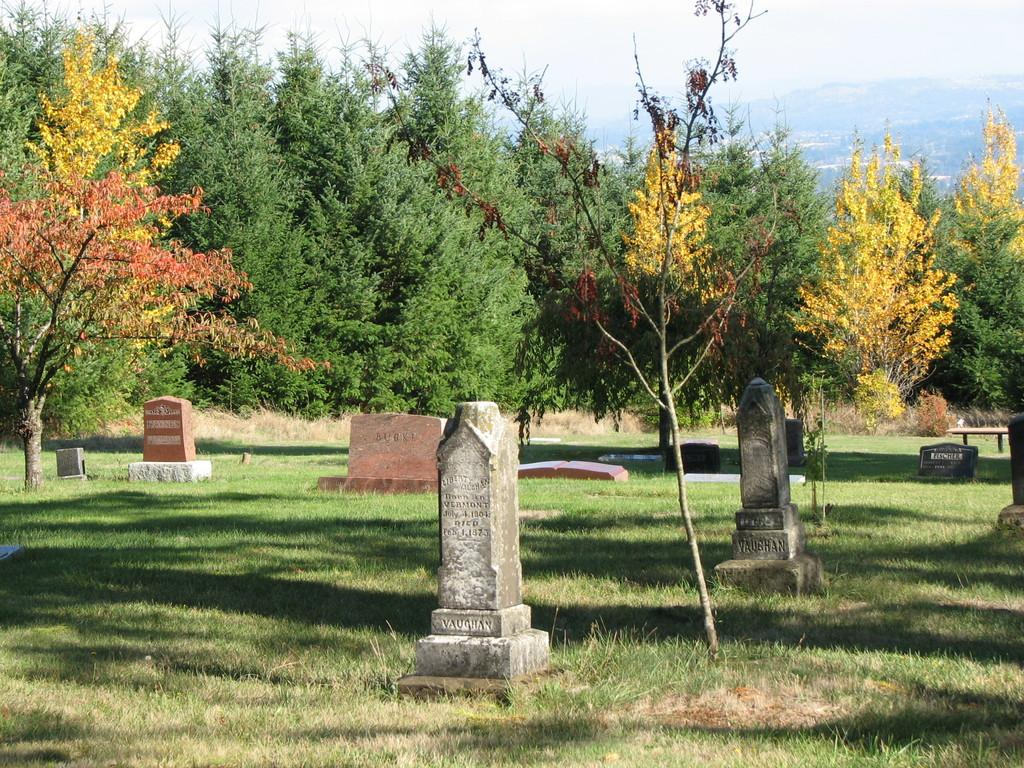What can be seen on the ground in the image? There are graves on the ground in the image. What is a piece of furniture that can be seen in the image? There is a bench in the image. What type of vegetation is present in the image? There is grass in the image. What other natural elements can be seen in the image? There are trees in the image. What is visible in the distance in the image? There is a mountain visible in the background of the image. What else can be seen in the background of the image? The sky is visible in the background of the image. Can you see the sea from the bench in the image? There is no sea visible in the image; instead, there is a mountain in the background. Is there a tramp playing with the trees in the image? There is no tramp present in the image; it features graves, a bench, grass, trees, a mountain, and the sky. 